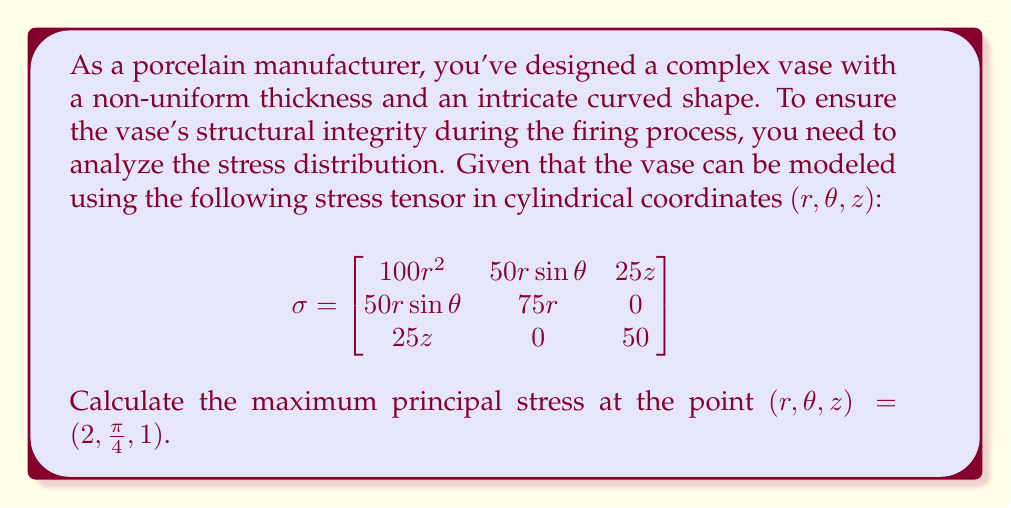Solve this math problem. To find the maximum principal stress, we need to calculate the eigenvalues of the stress tensor at the given point. The largest eigenvalue will be the maximum principal stress.

1. First, let's evaluate the stress tensor at the point $(2, \frac{\pi}{4}, 1)$:

$$\sigma_{(2,\frac{\pi}{4},1)} = \begin{bmatrix}
100(2)^2 & 50(2)\sin(\frac{\pi}{4}) & 25(1) \\
50(2)\sin(\frac{\pi}{4}) & 75(2) & 0 \\
25(1) & 0 & 50
\end{bmatrix}$$

$$= \begin{bmatrix}
400 & 50\sqrt{2} & 25 \\
50\sqrt{2} & 150 & 0 \\
25 & 0 & 50
\end{bmatrix}$$

2. To find the eigenvalues, we need to solve the characteristic equation:

$$\det(\sigma - \lambda I) = 0$$

Where $I$ is the 3x3 identity matrix and $\lambda$ are the eigenvalues.

3. Expanding the determinant:

$$\begin{vmatrix}
400 - \lambda & 50\sqrt{2} & 25 \\
50\sqrt{2} & 150 - \lambda & 0 \\
25 & 0 & 50 - \lambda
\end{vmatrix} = 0$$

4. This leads to the characteristic polynomial:

$$(400 - \lambda)(150 - \lambda)(50 - \lambda) - 5000(50 - \lambda) - 625(150 - \lambda) = 0$$

5. Simplifying:

$$\lambda^3 - 600\lambda^2 + 83750\lambda - 3125000 = 0$$

6. This cubic equation can be solved numerically. The three roots (eigenvalues) are approximately:

$\lambda_1 \approx 414.21$
$\lambda_2 \approx 135.79$
$\lambda_3 \approx 50.00$

7. The maximum principal stress is the largest eigenvalue:

$$\lambda_{\text{max}} = \lambda_1 \approx 414.21$$
Answer: The maximum principal stress at the point $(2, \frac{\pi}{4}, 1)$ is approximately 414.21 units of stress. 